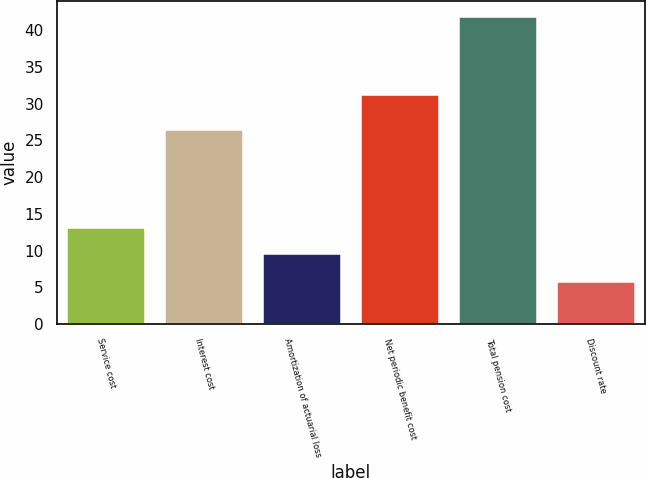Convert chart to OTSL. <chart><loc_0><loc_0><loc_500><loc_500><bar_chart><fcel>Service cost<fcel>Interest cost<fcel>Amortization of actuarial loss<fcel>Net periodic benefit cost<fcel>Total pension cost<fcel>Discount rate<nl><fcel>13.11<fcel>26.4<fcel>9.5<fcel>31.1<fcel>41.8<fcel>5.75<nl></chart> 